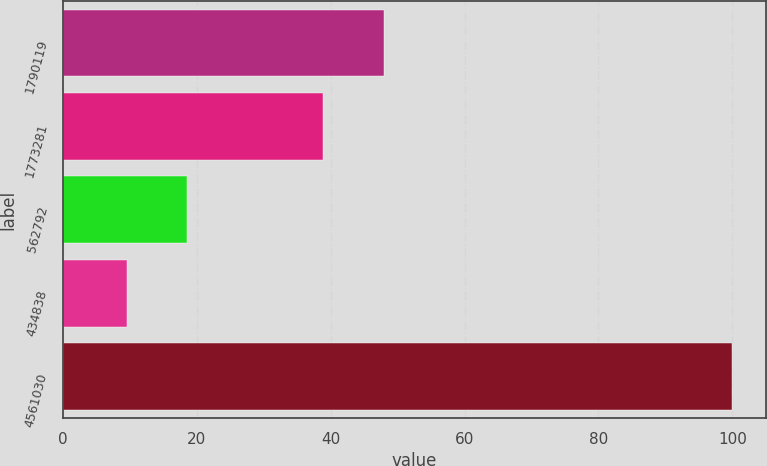<chart> <loc_0><loc_0><loc_500><loc_500><bar_chart><fcel>1790119<fcel>1773281<fcel>562792<fcel>434838<fcel>4561030<nl><fcel>47.95<fcel>38.9<fcel>18.55<fcel>9.5<fcel>100<nl></chart> 